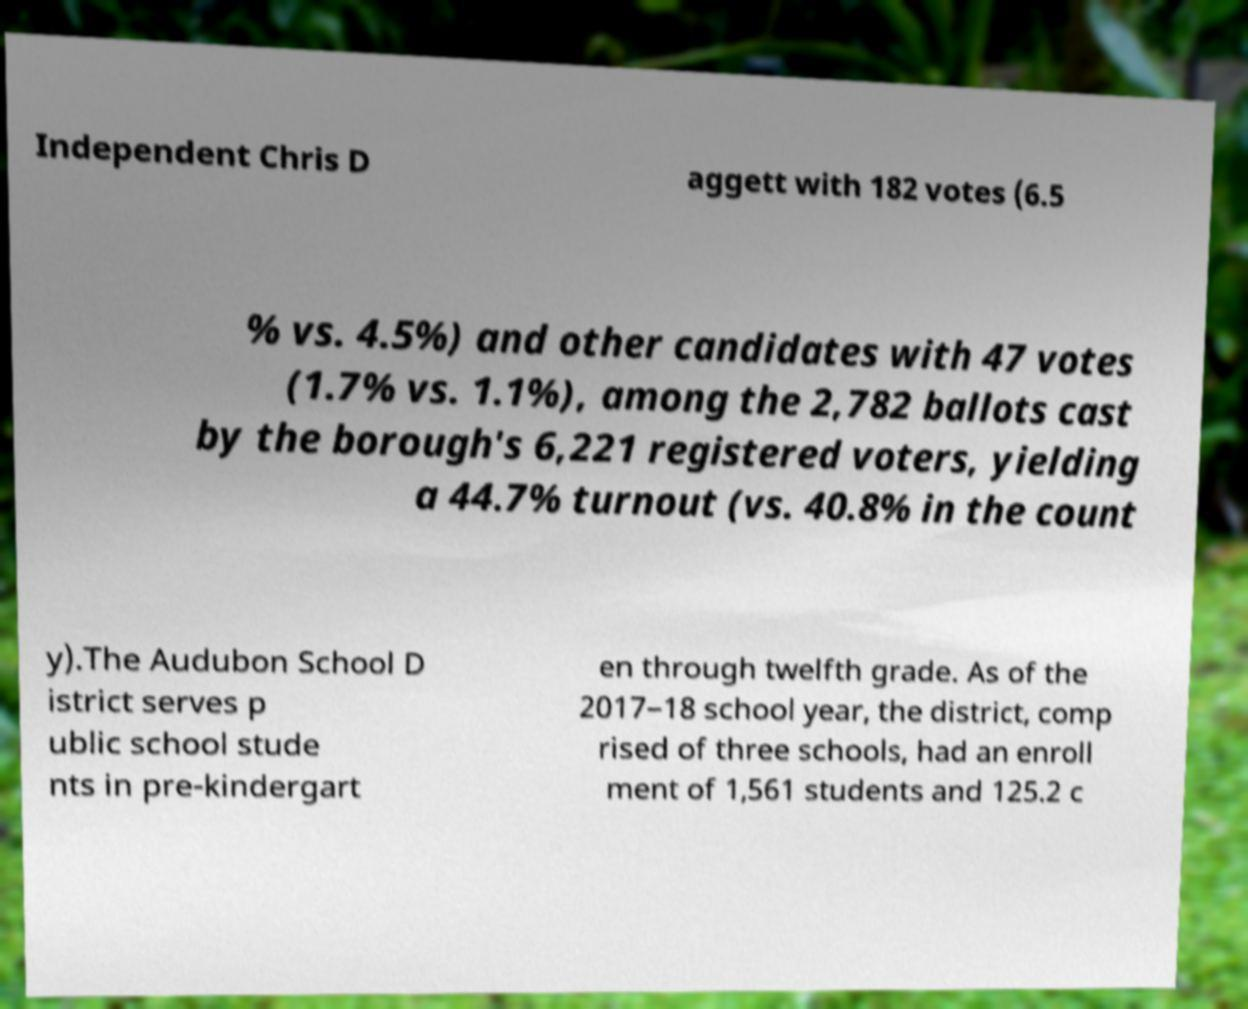There's text embedded in this image that I need extracted. Can you transcribe it verbatim? Independent Chris D aggett with 182 votes (6.5 % vs. 4.5%) and other candidates with 47 votes (1.7% vs. 1.1%), among the 2,782 ballots cast by the borough's 6,221 registered voters, yielding a 44.7% turnout (vs. 40.8% in the count y).The Audubon School D istrict serves p ublic school stude nts in pre-kindergart en through twelfth grade. As of the 2017–18 school year, the district, comp rised of three schools, had an enroll ment of 1,561 students and 125.2 c 